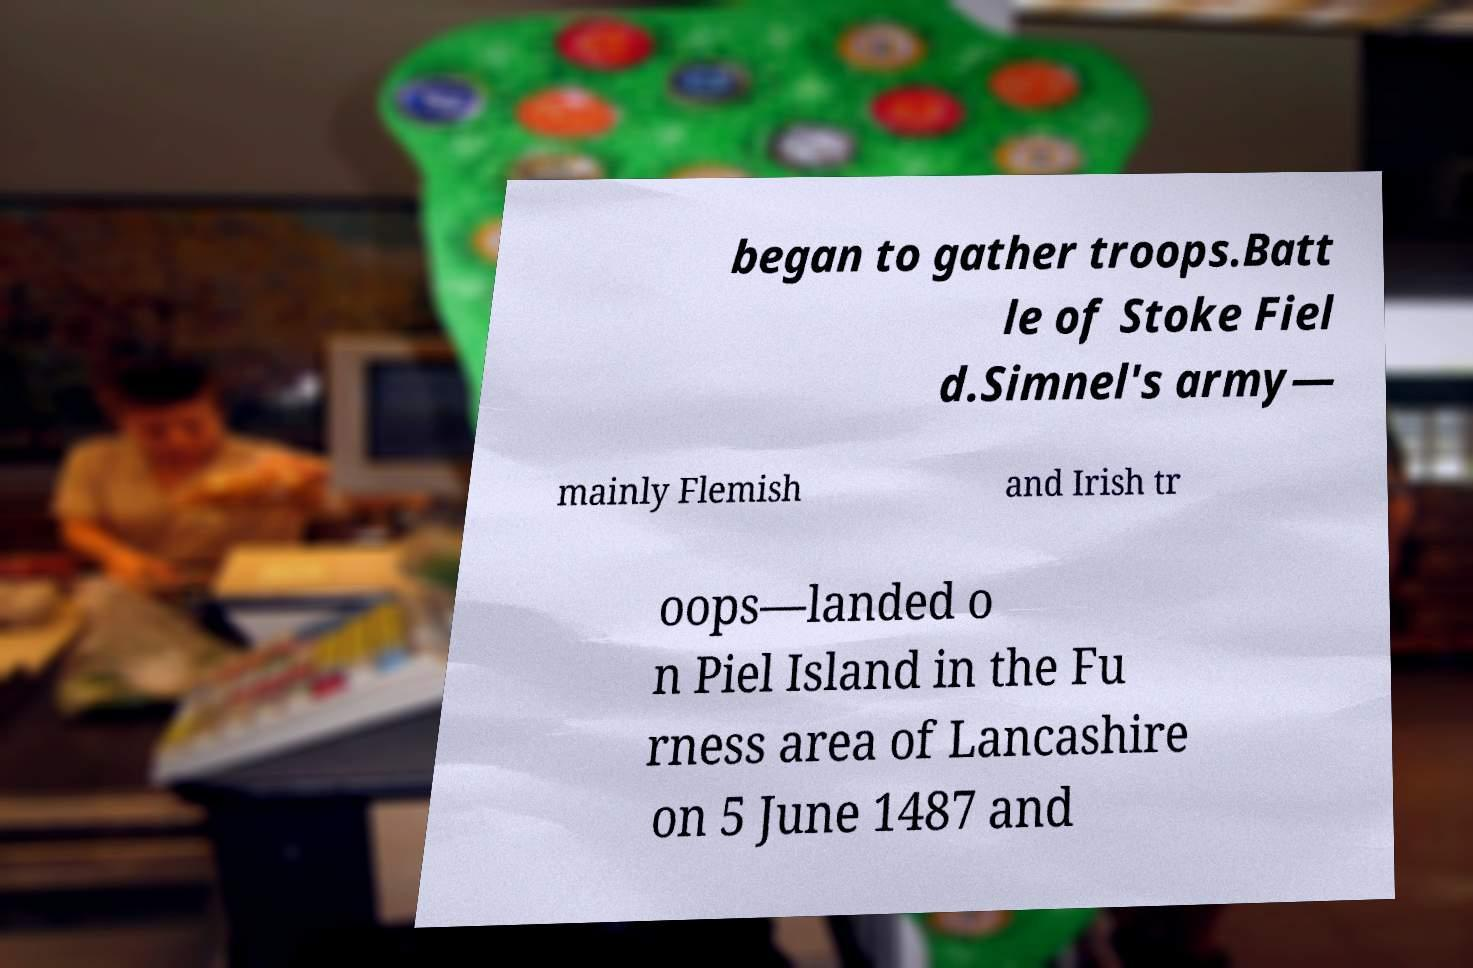I need the written content from this picture converted into text. Can you do that? began to gather troops.Batt le of Stoke Fiel d.Simnel's army— mainly Flemish and Irish tr oops—landed o n Piel Island in the Fu rness area of Lancashire on 5 June 1487 and 